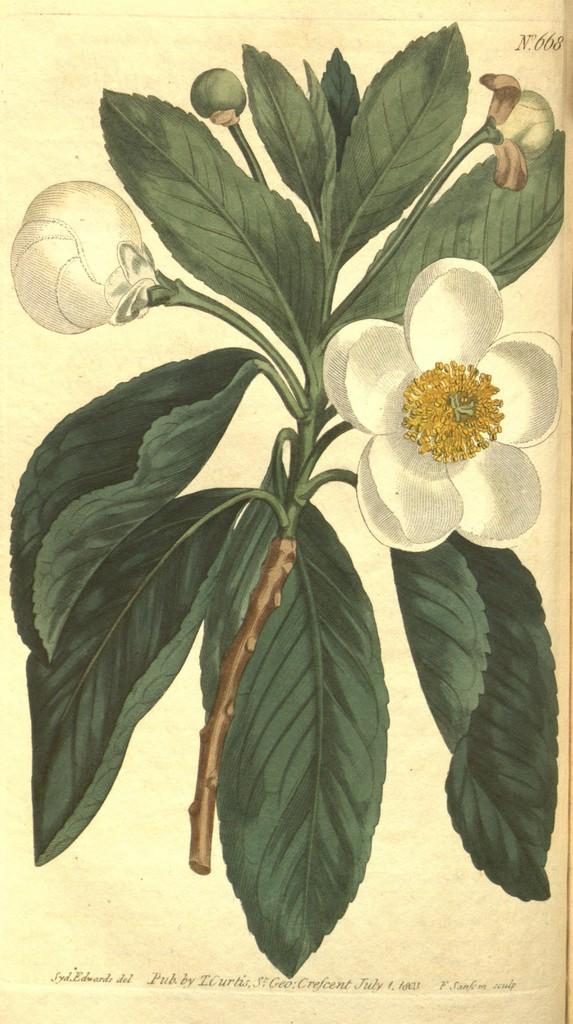Could you give a brief overview of what you see in this image? In this image I can see a drawing of a white flowers plant. 